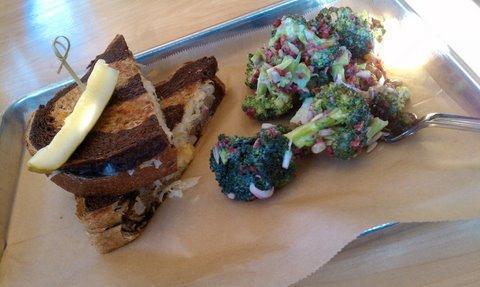How many trays are there?
Give a very brief answer. 1. How many sandwiches can be seen?
Give a very brief answer. 2. How many horses are in the picture?
Give a very brief answer. 0. 